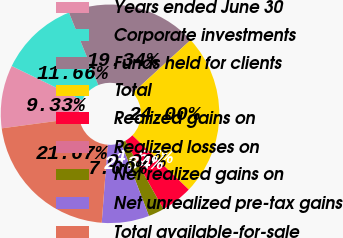<chart> <loc_0><loc_0><loc_500><loc_500><pie_chart><fcel>Years ended June 30<fcel>Corporate investments<fcel>Funds held for clients<fcel>Total<fcel>Realized gains on<fcel>Realized losses on<fcel>Net realized gains on<fcel>Net unrealized pre-tax gains<fcel>Total available-for-sale<nl><fcel>9.33%<fcel>11.66%<fcel>19.34%<fcel>24.0%<fcel>4.67%<fcel>0.0%<fcel>2.34%<fcel>7.0%<fcel>21.67%<nl></chart> 